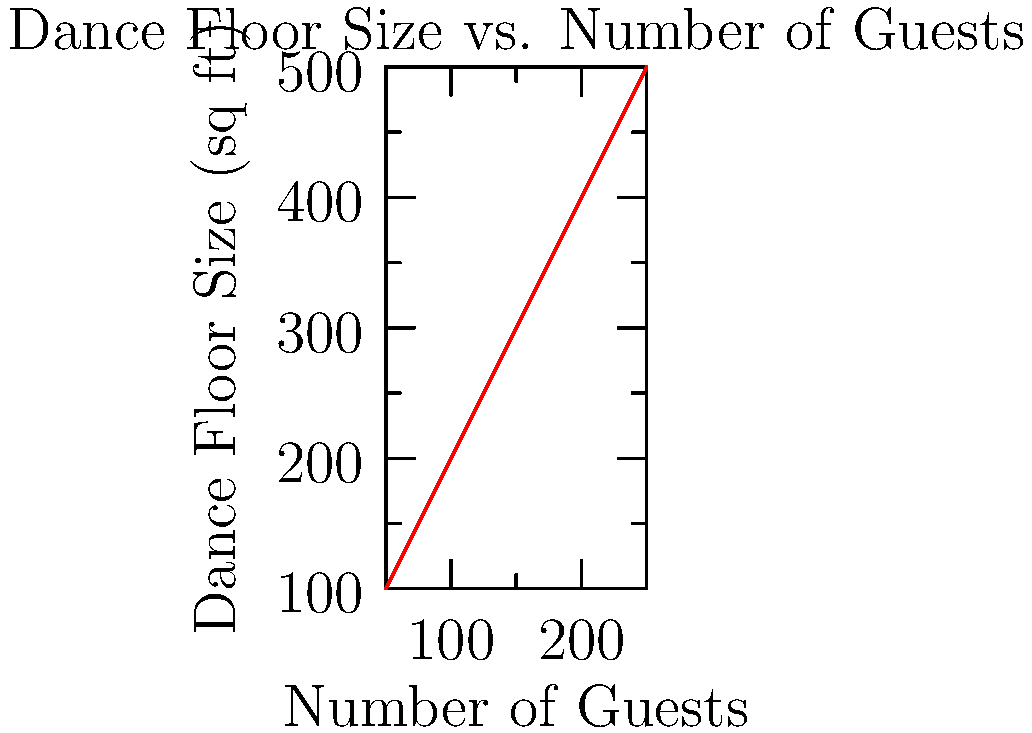As the wedding planner responsible for organizing the perfect reception, you need to determine the appropriate dance floor size. Using the graph provided, estimate the required dance floor size in square feet for a wedding with 175 guests. To estimate the required dance floor size for 175 guests, we need to follow these steps:

1. Locate 175 guests on the x-axis of the graph.
2. Draw an imaginary vertical line from this point until it intersects the plotted line.
3. From the intersection point, draw an imaginary horizontal line to the y-axis.
4. Read the corresponding value on the y-axis.

The graph shows a linear relationship between the number of guests and the dance floor size. We can see that:

- 150 guests correspond to approximately 300 sq ft
- 200 guests correspond to approximately 400 sq ft

Since 175 is halfway between 150 and 200, we can estimate that the required dance floor size would be halfway between 300 and 400 sq ft.

Calculating: $300 + (400 - 300) / 2 = 300 + 50 = 350$ sq ft

Therefore, the estimated dance floor size for 175 guests is approximately 350 square feet.
Answer: 350 sq ft 